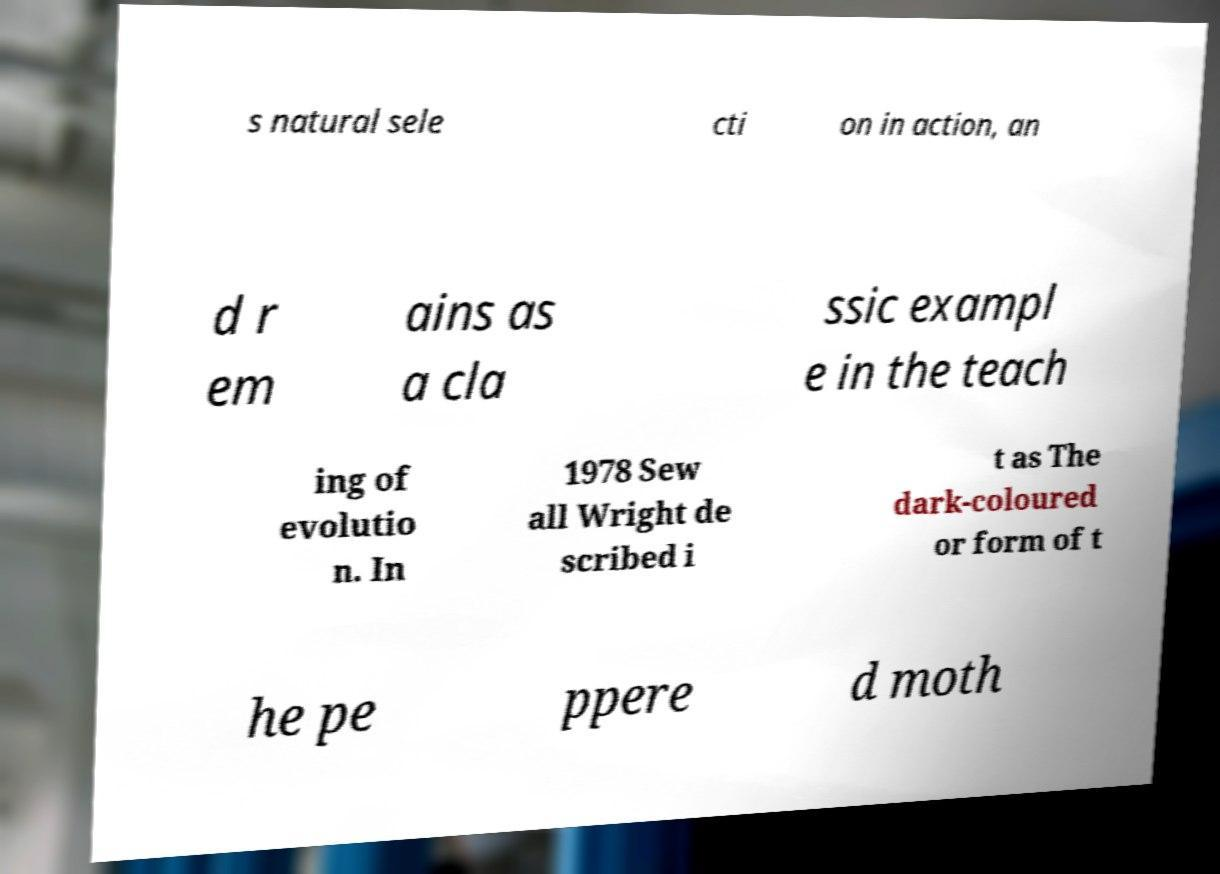Please identify and transcribe the text found in this image. s natural sele cti on in action, an d r em ains as a cla ssic exampl e in the teach ing of evolutio n. In 1978 Sew all Wright de scribed i t as The dark-coloured or form of t he pe ppere d moth 